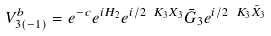Convert formula to latex. <formula><loc_0><loc_0><loc_500><loc_500>V ^ { b } _ { 3 ( - 1 ) } = e ^ { - c } e ^ { i H _ { 2 } } e ^ { i / 2 \ K _ { 3 } X _ { 3 } } \bar { G } _ { 3 } e ^ { i / 2 \ K _ { 3 } \bar { X } _ { 3 } }</formula> 